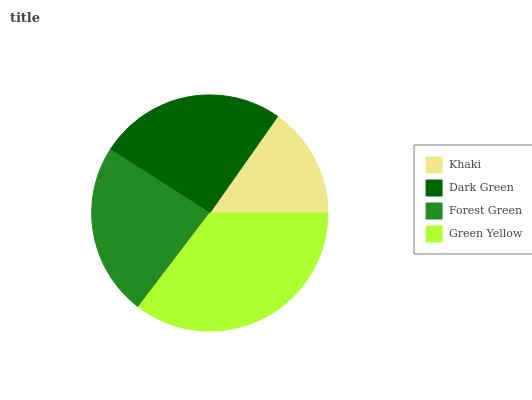Is Khaki the minimum?
Answer yes or no. Yes. Is Green Yellow the maximum?
Answer yes or no. Yes. Is Dark Green the minimum?
Answer yes or no. No. Is Dark Green the maximum?
Answer yes or no. No. Is Dark Green greater than Khaki?
Answer yes or no. Yes. Is Khaki less than Dark Green?
Answer yes or no. Yes. Is Khaki greater than Dark Green?
Answer yes or no. No. Is Dark Green less than Khaki?
Answer yes or no. No. Is Dark Green the high median?
Answer yes or no. Yes. Is Forest Green the low median?
Answer yes or no. Yes. Is Forest Green the high median?
Answer yes or no. No. Is Dark Green the low median?
Answer yes or no. No. 